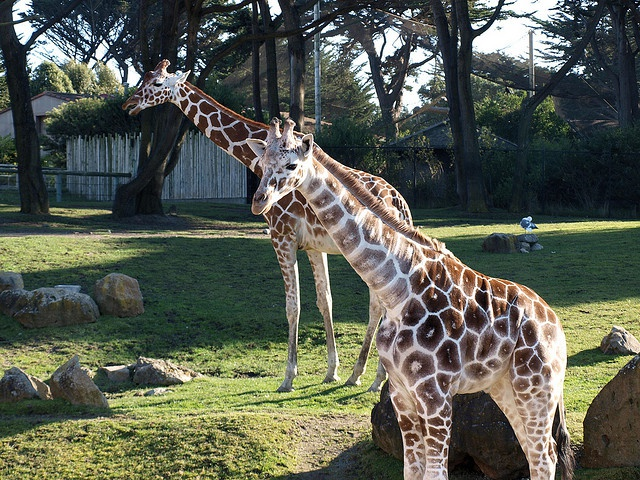Describe the objects in this image and their specific colors. I can see giraffe in black, lightgray, gray, and darkgray tones, giraffe in black, darkgray, gray, and maroon tones, and bird in black, blue, lightblue, navy, and gray tones in this image. 